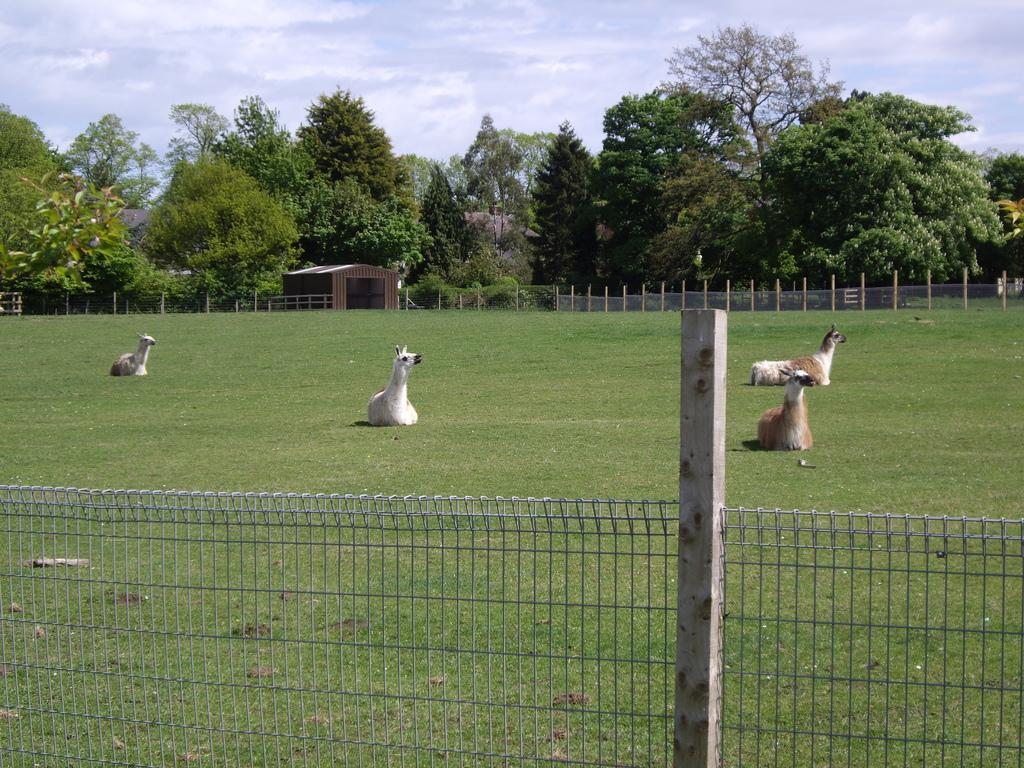In one or two sentences, can you explain what this image depicts? In this image in front there is a metal fence. There is a wooden pole. There are animals on the surface of the grass. In the background of the image there is a garage. There is a metal fence. There are trees. At the top of the image there is sky. 